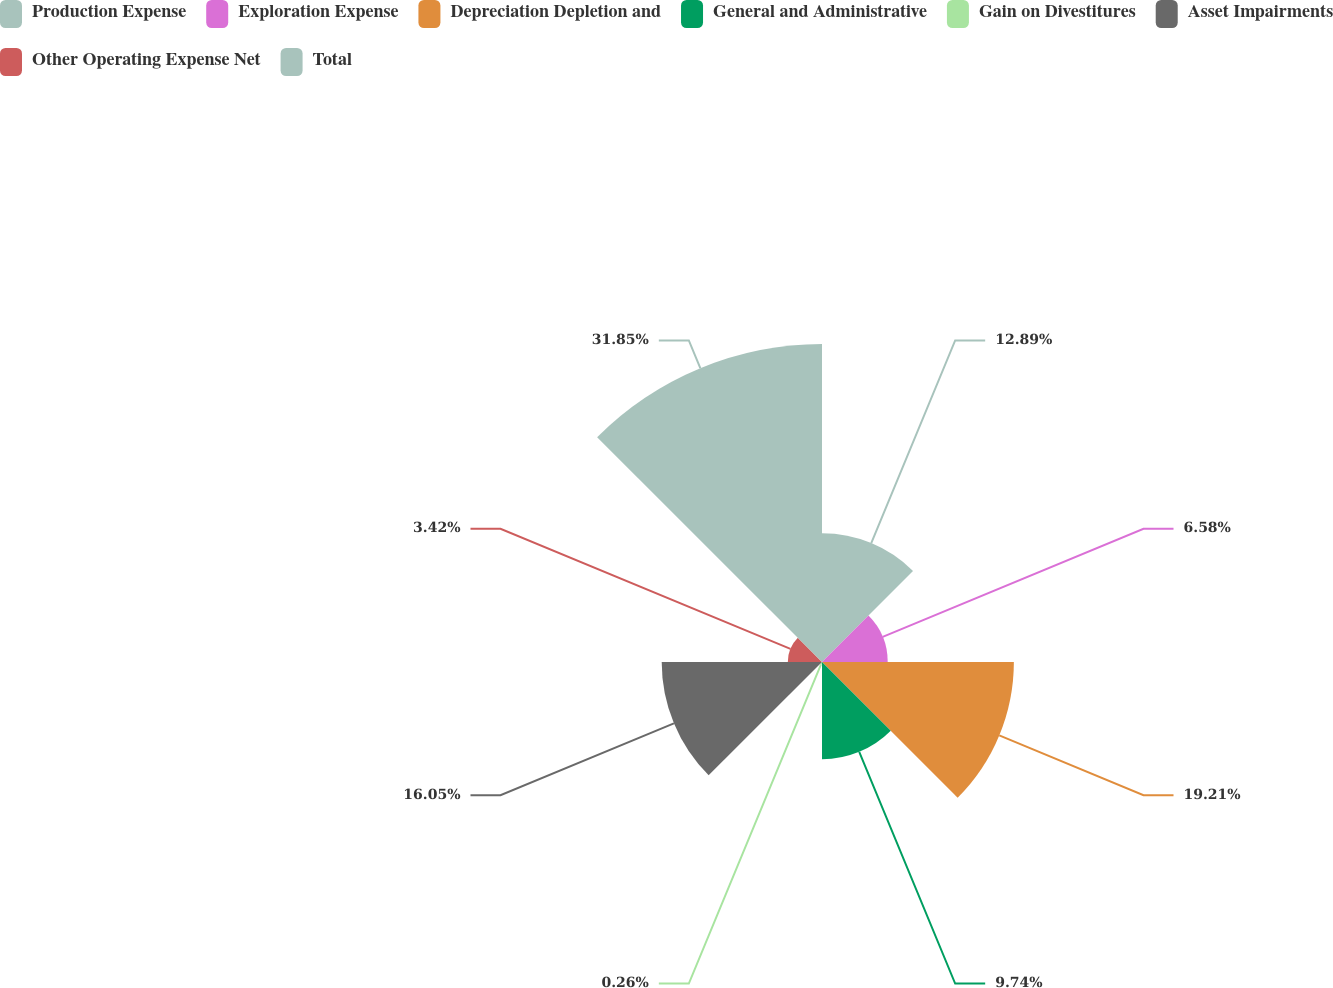Convert chart. <chart><loc_0><loc_0><loc_500><loc_500><pie_chart><fcel>Production Expense<fcel>Exploration Expense<fcel>Depreciation Depletion and<fcel>General and Administrative<fcel>Gain on Divestitures<fcel>Asset Impairments<fcel>Other Operating Expense Net<fcel>Total<nl><fcel>12.89%<fcel>6.58%<fcel>19.21%<fcel>9.74%<fcel>0.26%<fcel>16.05%<fcel>3.42%<fcel>31.84%<nl></chart> 